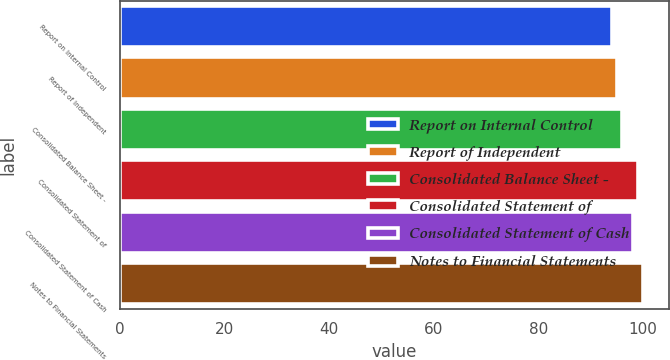Convert chart. <chart><loc_0><loc_0><loc_500><loc_500><bar_chart><fcel>Report on Internal Control<fcel>Report of Independent<fcel>Consolidated Balance Sheet -<fcel>Consolidated Statement of<fcel>Consolidated Statement of Cash<fcel>Notes to Financial Statements<nl><fcel>94<fcel>95<fcel>96<fcel>99<fcel>98<fcel>100<nl></chart> 